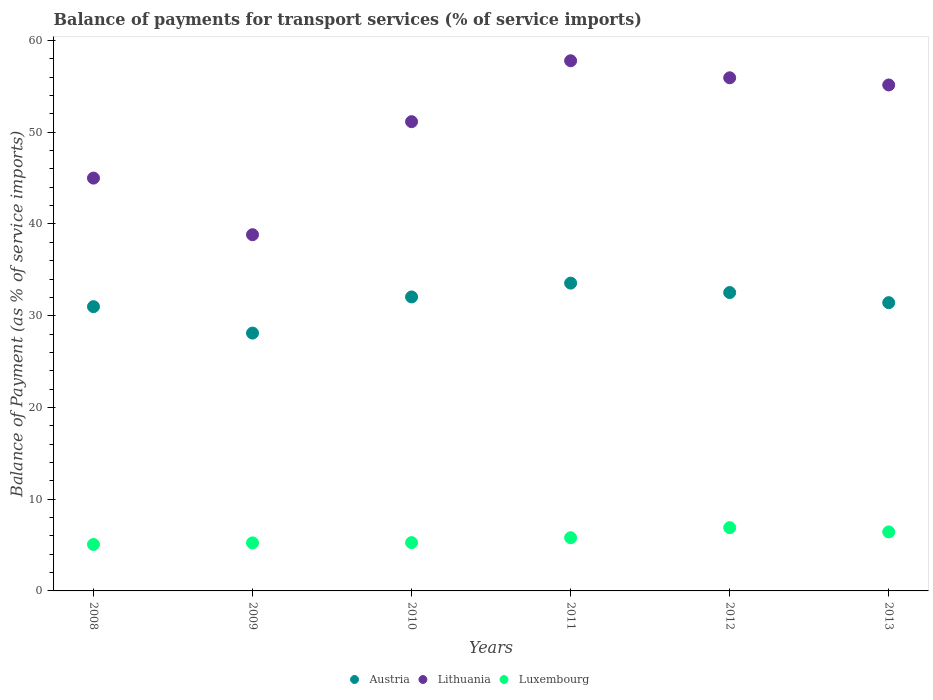How many different coloured dotlines are there?
Give a very brief answer. 3. Is the number of dotlines equal to the number of legend labels?
Provide a short and direct response. Yes. What is the balance of payments for transport services in Luxembourg in 2009?
Your answer should be very brief. 5.23. Across all years, what is the maximum balance of payments for transport services in Austria?
Provide a succinct answer. 33.55. Across all years, what is the minimum balance of payments for transport services in Austria?
Offer a terse response. 28.11. In which year was the balance of payments for transport services in Luxembourg maximum?
Give a very brief answer. 2012. What is the total balance of payments for transport services in Luxembourg in the graph?
Your answer should be compact. 34.7. What is the difference between the balance of payments for transport services in Lithuania in 2008 and that in 2010?
Your answer should be compact. -6.15. What is the difference between the balance of payments for transport services in Austria in 2009 and the balance of payments for transport services in Luxembourg in 2012?
Your answer should be compact. 21.21. What is the average balance of payments for transport services in Austria per year?
Your answer should be very brief. 31.44. In the year 2012, what is the difference between the balance of payments for transport services in Luxembourg and balance of payments for transport services in Lithuania?
Make the answer very short. -49.04. In how many years, is the balance of payments for transport services in Lithuania greater than 8 %?
Offer a terse response. 6. What is the ratio of the balance of payments for transport services in Lithuania in 2009 to that in 2010?
Your answer should be compact. 0.76. Is the difference between the balance of payments for transport services in Luxembourg in 2010 and 2011 greater than the difference between the balance of payments for transport services in Lithuania in 2010 and 2011?
Your answer should be very brief. Yes. What is the difference between the highest and the second highest balance of payments for transport services in Lithuania?
Offer a terse response. 1.86. What is the difference between the highest and the lowest balance of payments for transport services in Lithuania?
Your answer should be very brief. 18.96. Is the sum of the balance of payments for transport services in Austria in 2011 and 2012 greater than the maximum balance of payments for transport services in Luxembourg across all years?
Your answer should be very brief. Yes. Is it the case that in every year, the sum of the balance of payments for transport services in Luxembourg and balance of payments for transport services in Austria  is greater than the balance of payments for transport services in Lithuania?
Ensure brevity in your answer.  No. How many dotlines are there?
Make the answer very short. 3. How many years are there in the graph?
Give a very brief answer. 6. Does the graph contain any zero values?
Offer a very short reply. No. Does the graph contain grids?
Ensure brevity in your answer.  No. How are the legend labels stacked?
Make the answer very short. Horizontal. What is the title of the graph?
Keep it short and to the point. Balance of payments for transport services (% of service imports). What is the label or title of the Y-axis?
Provide a short and direct response. Balance of Payment (as % of service imports). What is the Balance of Payment (as % of service imports) of Austria in 2008?
Provide a short and direct response. 30.99. What is the Balance of Payment (as % of service imports) of Lithuania in 2008?
Provide a short and direct response. 45. What is the Balance of Payment (as % of service imports) of Luxembourg in 2008?
Give a very brief answer. 5.07. What is the Balance of Payment (as % of service imports) of Austria in 2009?
Your response must be concise. 28.11. What is the Balance of Payment (as % of service imports) of Lithuania in 2009?
Keep it short and to the point. 38.83. What is the Balance of Payment (as % of service imports) of Luxembourg in 2009?
Your answer should be compact. 5.23. What is the Balance of Payment (as % of service imports) of Austria in 2010?
Offer a terse response. 32.05. What is the Balance of Payment (as % of service imports) in Lithuania in 2010?
Your answer should be very brief. 51.15. What is the Balance of Payment (as % of service imports) of Luxembourg in 2010?
Provide a short and direct response. 5.27. What is the Balance of Payment (as % of service imports) in Austria in 2011?
Provide a succinct answer. 33.55. What is the Balance of Payment (as % of service imports) of Lithuania in 2011?
Give a very brief answer. 57.79. What is the Balance of Payment (as % of service imports) in Luxembourg in 2011?
Your answer should be very brief. 5.8. What is the Balance of Payment (as % of service imports) in Austria in 2012?
Your answer should be very brief. 32.53. What is the Balance of Payment (as % of service imports) in Lithuania in 2012?
Offer a terse response. 55.94. What is the Balance of Payment (as % of service imports) of Luxembourg in 2012?
Keep it short and to the point. 6.9. What is the Balance of Payment (as % of service imports) of Austria in 2013?
Offer a very short reply. 31.42. What is the Balance of Payment (as % of service imports) of Lithuania in 2013?
Your answer should be very brief. 55.16. What is the Balance of Payment (as % of service imports) of Luxembourg in 2013?
Provide a succinct answer. 6.43. Across all years, what is the maximum Balance of Payment (as % of service imports) in Austria?
Provide a succinct answer. 33.55. Across all years, what is the maximum Balance of Payment (as % of service imports) in Lithuania?
Make the answer very short. 57.79. Across all years, what is the maximum Balance of Payment (as % of service imports) of Luxembourg?
Ensure brevity in your answer.  6.9. Across all years, what is the minimum Balance of Payment (as % of service imports) in Austria?
Keep it short and to the point. 28.11. Across all years, what is the minimum Balance of Payment (as % of service imports) in Lithuania?
Your response must be concise. 38.83. Across all years, what is the minimum Balance of Payment (as % of service imports) in Luxembourg?
Offer a terse response. 5.07. What is the total Balance of Payment (as % of service imports) of Austria in the graph?
Provide a short and direct response. 188.65. What is the total Balance of Payment (as % of service imports) in Lithuania in the graph?
Keep it short and to the point. 303.88. What is the total Balance of Payment (as % of service imports) of Luxembourg in the graph?
Give a very brief answer. 34.7. What is the difference between the Balance of Payment (as % of service imports) in Austria in 2008 and that in 2009?
Ensure brevity in your answer.  2.88. What is the difference between the Balance of Payment (as % of service imports) of Lithuania in 2008 and that in 2009?
Make the answer very short. 6.17. What is the difference between the Balance of Payment (as % of service imports) in Luxembourg in 2008 and that in 2009?
Your answer should be very brief. -0.17. What is the difference between the Balance of Payment (as % of service imports) of Austria in 2008 and that in 2010?
Provide a succinct answer. -1.06. What is the difference between the Balance of Payment (as % of service imports) of Lithuania in 2008 and that in 2010?
Your answer should be compact. -6.15. What is the difference between the Balance of Payment (as % of service imports) in Luxembourg in 2008 and that in 2010?
Give a very brief answer. -0.2. What is the difference between the Balance of Payment (as % of service imports) of Austria in 2008 and that in 2011?
Your answer should be very brief. -2.56. What is the difference between the Balance of Payment (as % of service imports) of Lithuania in 2008 and that in 2011?
Provide a short and direct response. -12.79. What is the difference between the Balance of Payment (as % of service imports) of Luxembourg in 2008 and that in 2011?
Provide a short and direct response. -0.73. What is the difference between the Balance of Payment (as % of service imports) in Austria in 2008 and that in 2012?
Your answer should be very brief. -1.54. What is the difference between the Balance of Payment (as % of service imports) in Lithuania in 2008 and that in 2012?
Offer a terse response. -10.94. What is the difference between the Balance of Payment (as % of service imports) of Luxembourg in 2008 and that in 2012?
Your response must be concise. -1.83. What is the difference between the Balance of Payment (as % of service imports) in Austria in 2008 and that in 2013?
Make the answer very short. -0.44. What is the difference between the Balance of Payment (as % of service imports) of Lithuania in 2008 and that in 2013?
Your response must be concise. -10.15. What is the difference between the Balance of Payment (as % of service imports) of Luxembourg in 2008 and that in 2013?
Make the answer very short. -1.37. What is the difference between the Balance of Payment (as % of service imports) of Austria in 2009 and that in 2010?
Offer a very short reply. -3.94. What is the difference between the Balance of Payment (as % of service imports) in Lithuania in 2009 and that in 2010?
Give a very brief answer. -12.32. What is the difference between the Balance of Payment (as % of service imports) of Luxembourg in 2009 and that in 2010?
Keep it short and to the point. -0.03. What is the difference between the Balance of Payment (as % of service imports) in Austria in 2009 and that in 2011?
Offer a very short reply. -5.45. What is the difference between the Balance of Payment (as % of service imports) in Lithuania in 2009 and that in 2011?
Offer a very short reply. -18.96. What is the difference between the Balance of Payment (as % of service imports) in Luxembourg in 2009 and that in 2011?
Provide a short and direct response. -0.56. What is the difference between the Balance of Payment (as % of service imports) in Austria in 2009 and that in 2012?
Offer a terse response. -4.42. What is the difference between the Balance of Payment (as % of service imports) of Lithuania in 2009 and that in 2012?
Give a very brief answer. -17.11. What is the difference between the Balance of Payment (as % of service imports) in Luxembourg in 2009 and that in 2012?
Offer a terse response. -1.66. What is the difference between the Balance of Payment (as % of service imports) in Austria in 2009 and that in 2013?
Offer a terse response. -3.32. What is the difference between the Balance of Payment (as % of service imports) of Lithuania in 2009 and that in 2013?
Make the answer very short. -16.33. What is the difference between the Balance of Payment (as % of service imports) of Luxembourg in 2009 and that in 2013?
Keep it short and to the point. -1.2. What is the difference between the Balance of Payment (as % of service imports) in Austria in 2010 and that in 2011?
Give a very brief answer. -1.5. What is the difference between the Balance of Payment (as % of service imports) in Lithuania in 2010 and that in 2011?
Your answer should be very brief. -6.64. What is the difference between the Balance of Payment (as % of service imports) of Luxembourg in 2010 and that in 2011?
Offer a terse response. -0.53. What is the difference between the Balance of Payment (as % of service imports) of Austria in 2010 and that in 2012?
Make the answer very short. -0.48. What is the difference between the Balance of Payment (as % of service imports) in Lithuania in 2010 and that in 2012?
Ensure brevity in your answer.  -4.78. What is the difference between the Balance of Payment (as % of service imports) in Luxembourg in 2010 and that in 2012?
Offer a terse response. -1.63. What is the difference between the Balance of Payment (as % of service imports) of Austria in 2010 and that in 2013?
Provide a succinct answer. 0.62. What is the difference between the Balance of Payment (as % of service imports) of Lithuania in 2010 and that in 2013?
Provide a succinct answer. -4. What is the difference between the Balance of Payment (as % of service imports) in Luxembourg in 2010 and that in 2013?
Offer a terse response. -1.17. What is the difference between the Balance of Payment (as % of service imports) of Austria in 2011 and that in 2012?
Provide a succinct answer. 1.03. What is the difference between the Balance of Payment (as % of service imports) of Lithuania in 2011 and that in 2012?
Ensure brevity in your answer.  1.86. What is the difference between the Balance of Payment (as % of service imports) in Luxembourg in 2011 and that in 2012?
Ensure brevity in your answer.  -1.1. What is the difference between the Balance of Payment (as % of service imports) of Austria in 2011 and that in 2013?
Offer a terse response. 2.13. What is the difference between the Balance of Payment (as % of service imports) in Lithuania in 2011 and that in 2013?
Provide a short and direct response. 2.64. What is the difference between the Balance of Payment (as % of service imports) in Luxembourg in 2011 and that in 2013?
Offer a very short reply. -0.63. What is the difference between the Balance of Payment (as % of service imports) of Austria in 2012 and that in 2013?
Make the answer very short. 1.1. What is the difference between the Balance of Payment (as % of service imports) in Lithuania in 2012 and that in 2013?
Keep it short and to the point. 0.78. What is the difference between the Balance of Payment (as % of service imports) in Luxembourg in 2012 and that in 2013?
Your response must be concise. 0.46. What is the difference between the Balance of Payment (as % of service imports) in Austria in 2008 and the Balance of Payment (as % of service imports) in Lithuania in 2009?
Give a very brief answer. -7.84. What is the difference between the Balance of Payment (as % of service imports) of Austria in 2008 and the Balance of Payment (as % of service imports) of Luxembourg in 2009?
Your answer should be very brief. 25.75. What is the difference between the Balance of Payment (as % of service imports) in Lithuania in 2008 and the Balance of Payment (as % of service imports) in Luxembourg in 2009?
Give a very brief answer. 39.77. What is the difference between the Balance of Payment (as % of service imports) in Austria in 2008 and the Balance of Payment (as % of service imports) in Lithuania in 2010?
Your answer should be very brief. -20.17. What is the difference between the Balance of Payment (as % of service imports) of Austria in 2008 and the Balance of Payment (as % of service imports) of Luxembourg in 2010?
Your response must be concise. 25.72. What is the difference between the Balance of Payment (as % of service imports) of Lithuania in 2008 and the Balance of Payment (as % of service imports) of Luxembourg in 2010?
Provide a succinct answer. 39.74. What is the difference between the Balance of Payment (as % of service imports) in Austria in 2008 and the Balance of Payment (as % of service imports) in Lithuania in 2011?
Your answer should be compact. -26.81. What is the difference between the Balance of Payment (as % of service imports) in Austria in 2008 and the Balance of Payment (as % of service imports) in Luxembourg in 2011?
Your answer should be very brief. 25.19. What is the difference between the Balance of Payment (as % of service imports) in Lithuania in 2008 and the Balance of Payment (as % of service imports) in Luxembourg in 2011?
Offer a terse response. 39.2. What is the difference between the Balance of Payment (as % of service imports) in Austria in 2008 and the Balance of Payment (as % of service imports) in Lithuania in 2012?
Offer a terse response. -24.95. What is the difference between the Balance of Payment (as % of service imports) in Austria in 2008 and the Balance of Payment (as % of service imports) in Luxembourg in 2012?
Your response must be concise. 24.09. What is the difference between the Balance of Payment (as % of service imports) of Lithuania in 2008 and the Balance of Payment (as % of service imports) of Luxembourg in 2012?
Your response must be concise. 38.1. What is the difference between the Balance of Payment (as % of service imports) in Austria in 2008 and the Balance of Payment (as % of service imports) in Lithuania in 2013?
Offer a terse response. -24.17. What is the difference between the Balance of Payment (as % of service imports) of Austria in 2008 and the Balance of Payment (as % of service imports) of Luxembourg in 2013?
Keep it short and to the point. 24.56. What is the difference between the Balance of Payment (as % of service imports) in Lithuania in 2008 and the Balance of Payment (as % of service imports) in Luxembourg in 2013?
Keep it short and to the point. 38.57. What is the difference between the Balance of Payment (as % of service imports) of Austria in 2009 and the Balance of Payment (as % of service imports) of Lithuania in 2010?
Your answer should be compact. -23.05. What is the difference between the Balance of Payment (as % of service imports) in Austria in 2009 and the Balance of Payment (as % of service imports) in Luxembourg in 2010?
Keep it short and to the point. 22.84. What is the difference between the Balance of Payment (as % of service imports) in Lithuania in 2009 and the Balance of Payment (as % of service imports) in Luxembourg in 2010?
Your response must be concise. 33.56. What is the difference between the Balance of Payment (as % of service imports) of Austria in 2009 and the Balance of Payment (as % of service imports) of Lithuania in 2011?
Keep it short and to the point. -29.69. What is the difference between the Balance of Payment (as % of service imports) in Austria in 2009 and the Balance of Payment (as % of service imports) in Luxembourg in 2011?
Make the answer very short. 22.31. What is the difference between the Balance of Payment (as % of service imports) in Lithuania in 2009 and the Balance of Payment (as % of service imports) in Luxembourg in 2011?
Offer a very short reply. 33.03. What is the difference between the Balance of Payment (as % of service imports) in Austria in 2009 and the Balance of Payment (as % of service imports) in Lithuania in 2012?
Provide a succinct answer. -27.83. What is the difference between the Balance of Payment (as % of service imports) in Austria in 2009 and the Balance of Payment (as % of service imports) in Luxembourg in 2012?
Offer a terse response. 21.21. What is the difference between the Balance of Payment (as % of service imports) of Lithuania in 2009 and the Balance of Payment (as % of service imports) of Luxembourg in 2012?
Your answer should be compact. 31.93. What is the difference between the Balance of Payment (as % of service imports) of Austria in 2009 and the Balance of Payment (as % of service imports) of Lithuania in 2013?
Provide a succinct answer. -27.05. What is the difference between the Balance of Payment (as % of service imports) of Austria in 2009 and the Balance of Payment (as % of service imports) of Luxembourg in 2013?
Your answer should be compact. 21.67. What is the difference between the Balance of Payment (as % of service imports) of Lithuania in 2009 and the Balance of Payment (as % of service imports) of Luxembourg in 2013?
Your answer should be compact. 32.4. What is the difference between the Balance of Payment (as % of service imports) in Austria in 2010 and the Balance of Payment (as % of service imports) in Lithuania in 2011?
Offer a terse response. -25.75. What is the difference between the Balance of Payment (as % of service imports) of Austria in 2010 and the Balance of Payment (as % of service imports) of Luxembourg in 2011?
Give a very brief answer. 26.25. What is the difference between the Balance of Payment (as % of service imports) of Lithuania in 2010 and the Balance of Payment (as % of service imports) of Luxembourg in 2011?
Give a very brief answer. 45.36. What is the difference between the Balance of Payment (as % of service imports) in Austria in 2010 and the Balance of Payment (as % of service imports) in Lithuania in 2012?
Offer a terse response. -23.89. What is the difference between the Balance of Payment (as % of service imports) of Austria in 2010 and the Balance of Payment (as % of service imports) of Luxembourg in 2012?
Provide a short and direct response. 25.15. What is the difference between the Balance of Payment (as % of service imports) in Lithuania in 2010 and the Balance of Payment (as % of service imports) in Luxembourg in 2012?
Give a very brief answer. 44.26. What is the difference between the Balance of Payment (as % of service imports) in Austria in 2010 and the Balance of Payment (as % of service imports) in Lithuania in 2013?
Your answer should be compact. -23.11. What is the difference between the Balance of Payment (as % of service imports) in Austria in 2010 and the Balance of Payment (as % of service imports) in Luxembourg in 2013?
Give a very brief answer. 25.62. What is the difference between the Balance of Payment (as % of service imports) in Lithuania in 2010 and the Balance of Payment (as % of service imports) in Luxembourg in 2013?
Give a very brief answer. 44.72. What is the difference between the Balance of Payment (as % of service imports) of Austria in 2011 and the Balance of Payment (as % of service imports) of Lithuania in 2012?
Offer a very short reply. -22.39. What is the difference between the Balance of Payment (as % of service imports) of Austria in 2011 and the Balance of Payment (as % of service imports) of Luxembourg in 2012?
Offer a terse response. 26.66. What is the difference between the Balance of Payment (as % of service imports) in Lithuania in 2011 and the Balance of Payment (as % of service imports) in Luxembourg in 2012?
Your answer should be compact. 50.9. What is the difference between the Balance of Payment (as % of service imports) in Austria in 2011 and the Balance of Payment (as % of service imports) in Lithuania in 2013?
Give a very brief answer. -21.6. What is the difference between the Balance of Payment (as % of service imports) in Austria in 2011 and the Balance of Payment (as % of service imports) in Luxembourg in 2013?
Keep it short and to the point. 27.12. What is the difference between the Balance of Payment (as % of service imports) in Lithuania in 2011 and the Balance of Payment (as % of service imports) in Luxembourg in 2013?
Give a very brief answer. 51.36. What is the difference between the Balance of Payment (as % of service imports) of Austria in 2012 and the Balance of Payment (as % of service imports) of Lithuania in 2013?
Provide a short and direct response. -22.63. What is the difference between the Balance of Payment (as % of service imports) in Austria in 2012 and the Balance of Payment (as % of service imports) in Luxembourg in 2013?
Ensure brevity in your answer.  26.09. What is the difference between the Balance of Payment (as % of service imports) in Lithuania in 2012 and the Balance of Payment (as % of service imports) in Luxembourg in 2013?
Make the answer very short. 49.51. What is the average Balance of Payment (as % of service imports) of Austria per year?
Offer a terse response. 31.44. What is the average Balance of Payment (as % of service imports) of Lithuania per year?
Your answer should be compact. 50.65. What is the average Balance of Payment (as % of service imports) of Luxembourg per year?
Your answer should be very brief. 5.78. In the year 2008, what is the difference between the Balance of Payment (as % of service imports) in Austria and Balance of Payment (as % of service imports) in Lithuania?
Provide a short and direct response. -14.01. In the year 2008, what is the difference between the Balance of Payment (as % of service imports) in Austria and Balance of Payment (as % of service imports) in Luxembourg?
Ensure brevity in your answer.  25.92. In the year 2008, what is the difference between the Balance of Payment (as % of service imports) in Lithuania and Balance of Payment (as % of service imports) in Luxembourg?
Your response must be concise. 39.94. In the year 2009, what is the difference between the Balance of Payment (as % of service imports) of Austria and Balance of Payment (as % of service imports) of Lithuania?
Give a very brief answer. -10.72. In the year 2009, what is the difference between the Balance of Payment (as % of service imports) in Austria and Balance of Payment (as % of service imports) in Luxembourg?
Give a very brief answer. 22.87. In the year 2009, what is the difference between the Balance of Payment (as % of service imports) of Lithuania and Balance of Payment (as % of service imports) of Luxembourg?
Give a very brief answer. 33.6. In the year 2010, what is the difference between the Balance of Payment (as % of service imports) of Austria and Balance of Payment (as % of service imports) of Lithuania?
Your answer should be compact. -19.11. In the year 2010, what is the difference between the Balance of Payment (as % of service imports) in Austria and Balance of Payment (as % of service imports) in Luxembourg?
Provide a short and direct response. 26.78. In the year 2010, what is the difference between the Balance of Payment (as % of service imports) in Lithuania and Balance of Payment (as % of service imports) in Luxembourg?
Your response must be concise. 45.89. In the year 2011, what is the difference between the Balance of Payment (as % of service imports) of Austria and Balance of Payment (as % of service imports) of Lithuania?
Give a very brief answer. -24.24. In the year 2011, what is the difference between the Balance of Payment (as % of service imports) of Austria and Balance of Payment (as % of service imports) of Luxembourg?
Provide a succinct answer. 27.75. In the year 2011, what is the difference between the Balance of Payment (as % of service imports) in Lithuania and Balance of Payment (as % of service imports) in Luxembourg?
Keep it short and to the point. 52. In the year 2012, what is the difference between the Balance of Payment (as % of service imports) of Austria and Balance of Payment (as % of service imports) of Lithuania?
Provide a short and direct response. -23.41. In the year 2012, what is the difference between the Balance of Payment (as % of service imports) of Austria and Balance of Payment (as % of service imports) of Luxembourg?
Ensure brevity in your answer.  25.63. In the year 2012, what is the difference between the Balance of Payment (as % of service imports) of Lithuania and Balance of Payment (as % of service imports) of Luxembourg?
Ensure brevity in your answer.  49.04. In the year 2013, what is the difference between the Balance of Payment (as % of service imports) in Austria and Balance of Payment (as % of service imports) in Lithuania?
Keep it short and to the point. -23.73. In the year 2013, what is the difference between the Balance of Payment (as % of service imports) of Austria and Balance of Payment (as % of service imports) of Luxembourg?
Your response must be concise. 24.99. In the year 2013, what is the difference between the Balance of Payment (as % of service imports) in Lithuania and Balance of Payment (as % of service imports) in Luxembourg?
Make the answer very short. 48.72. What is the ratio of the Balance of Payment (as % of service imports) in Austria in 2008 to that in 2009?
Ensure brevity in your answer.  1.1. What is the ratio of the Balance of Payment (as % of service imports) in Lithuania in 2008 to that in 2009?
Ensure brevity in your answer.  1.16. What is the ratio of the Balance of Payment (as % of service imports) of Austria in 2008 to that in 2010?
Give a very brief answer. 0.97. What is the ratio of the Balance of Payment (as % of service imports) of Lithuania in 2008 to that in 2010?
Provide a succinct answer. 0.88. What is the ratio of the Balance of Payment (as % of service imports) in Luxembourg in 2008 to that in 2010?
Your answer should be very brief. 0.96. What is the ratio of the Balance of Payment (as % of service imports) of Austria in 2008 to that in 2011?
Your answer should be compact. 0.92. What is the ratio of the Balance of Payment (as % of service imports) in Lithuania in 2008 to that in 2011?
Your answer should be compact. 0.78. What is the ratio of the Balance of Payment (as % of service imports) of Luxembourg in 2008 to that in 2011?
Your answer should be compact. 0.87. What is the ratio of the Balance of Payment (as % of service imports) of Austria in 2008 to that in 2012?
Offer a very short reply. 0.95. What is the ratio of the Balance of Payment (as % of service imports) in Lithuania in 2008 to that in 2012?
Offer a terse response. 0.8. What is the ratio of the Balance of Payment (as % of service imports) of Luxembourg in 2008 to that in 2012?
Offer a terse response. 0.73. What is the ratio of the Balance of Payment (as % of service imports) in Austria in 2008 to that in 2013?
Your answer should be very brief. 0.99. What is the ratio of the Balance of Payment (as % of service imports) of Lithuania in 2008 to that in 2013?
Keep it short and to the point. 0.82. What is the ratio of the Balance of Payment (as % of service imports) in Luxembourg in 2008 to that in 2013?
Your answer should be very brief. 0.79. What is the ratio of the Balance of Payment (as % of service imports) in Austria in 2009 to that in 2010?
Provide a short and direct response. 0.88. What is the ratio of the Balance of Payment (as % of service imports) in Lithuania in 2009 to that in 2010?
Make the answer very short. 0.76. What is the ratio of the Balance of Payment (as % of service imports) in Luxembourg in 2009 to that in 2010?
Give a very brief answer. 0.99. What is the ratio of the Balance of Payment (as % of service imports) of Austria in 2009 to that in 2011?
Offer a very short reply. 0.84. What is the ratio of the Balance of Payment (as % of service imports) of Lithuania in 2009 to that in 2011?
Keep it short and to the point. 0.67. What is the ratio of the Balance of Payment (as % of service imports) of Luxembourg in 2009 to that in 2011?
Offer a terse response. 0.9. What is the ratio of the Balance of Payment (as % of service imports) in Austria in 2009 to that in 2012?
Provide a succinct answer. 0.86. What is the ratio of the Balance of Payment (as % of service imports) of Lithuania in 2009 to that in 2012?
Keep it short and to the point. 0.69. What is the ratio of the Balance of Payment (as % of service imports) of Luxembourg in 2009 to that in 2012?
Provide a succinct answer. 0.76. What is the ratio of the Balance of Payment (as % of service imports) in Austria in 2009 to that in 2013?
Your answer should be compact. 0.89. What is the ratio of the Balance of Payment (as % of service imports) of Lithuania in 2009 to that in 2013?
Give a very brief answer. 0.7. What is the ratio of the Balance of Payment (as % of service imports) of Luxembourg in 2009 to that in 2013?
Make the answer very short. 0.81. What is the ratio of the Balance of Payment (as % of service imports) in Austria in 2010 to that in 2011?
Offer a terse response. 0.96. What is the ratio of the Balance of Payment (as % of service imports) in Lithuania in 2010 to that in 2011?
Provide a short and direct response. 0.89. What is the ratio of the Balance of Payment (as % of service imports) of Luxembourg in 2010 to that in 2011?
Your answer should be compact. 0.91. What is the ratio of the Balance of Payment (as % of service imports) in Lithuania in 2010 to that in 2012?
Give a very brief answer. 0.91. What is the ratio of the Balance of Payment (as % of service imports) in Luxembourg in 2010 to that in 2012?
Your answer should be compact. 0.76. What is the ratio of the Balance of Payment (as % of service imports) of Austria in 2010 to that in 2013?
Give a very brief answer. 1.02. What is the ratio of the Balance of Payment (as % of service imports) in Lithuania in 2010 to that in 2013?
Offer a very short reply. 0.93. What is the ratio of the Balance of Payment (as % of service imports) of Luxembourg in 2010 to that in 2013?
Provide a short and direct response. 0.82. What is the ratio of the Balance of Payment (as % of service imports) in Austria in 2011 to that in 2012?
Provide a short and direct response. 1.03. What is the ratio of the Balance of Payment (as % of service imports) of Lithuania in 2011 to that in 2012?
Keep it short and to the point. 1.03. What is the ratio of the Balance of Payment (as % of service imports) of Luxembourg in 2011 to that in 2012?
Your answer should be very brief. 0.84. What is the ratio of the Balance of Payment (as % of service imports) in Austria in 2011 to that in 2013?
Offer a terse response. 1.07. What is the ratio of the Balance of Payment (as % of service imports) of Lithuania in 2011 to that in 2013?
Keep it short and to the point. 1.05. What is the ratio of the Balance of Payment (as % of service imports) in Luxembourg in 2011 to that in 2013?
Your answer should be very brief. 0.9. What is the ratio of the Balance of Payment (as % of service imports) in Austria in 2012 to that in 2013?
Provide a short and direct response. 1.04. What is the ratio of the Balance of Payment (as % of service imports) of Lithuania in 2012 to that in 2013?
Ensure brevity in your answer.  1.01. What is the ratio of the Balance of Payment (as % of service imports) of Luxembourg in 2012 to that in 2013?
Your answer should be compact. 1.07. What is the difference between the highest and the second highest Balance of Payment (as % of service imports) in Austria?
Your response must be concise. 1.03. What is the difference between the highest and the second highest Balance of Payment (as % of service imports) in Lithuania?
Provide a succinct answer. 1.86. What is the difference between the highest and the second highest Balance of Payment (as % of service imports) of Luxembourg?
Your response must be concise. 0.46. What is the difference between the highest and the lowest Balance of Payment (as % of service imports) of Austria?
Ensure brevity in your answer.  5.45. What is the difference between the highest and the lowest Balance of Payment (as % of service imports) in Lithuania?
Keep it short and to the point. 18.96. What is the difference between the highest and the lowest Balance of Payment (as % of service imports) of Luxembourg?
Offer a very short reply. 1.83. 